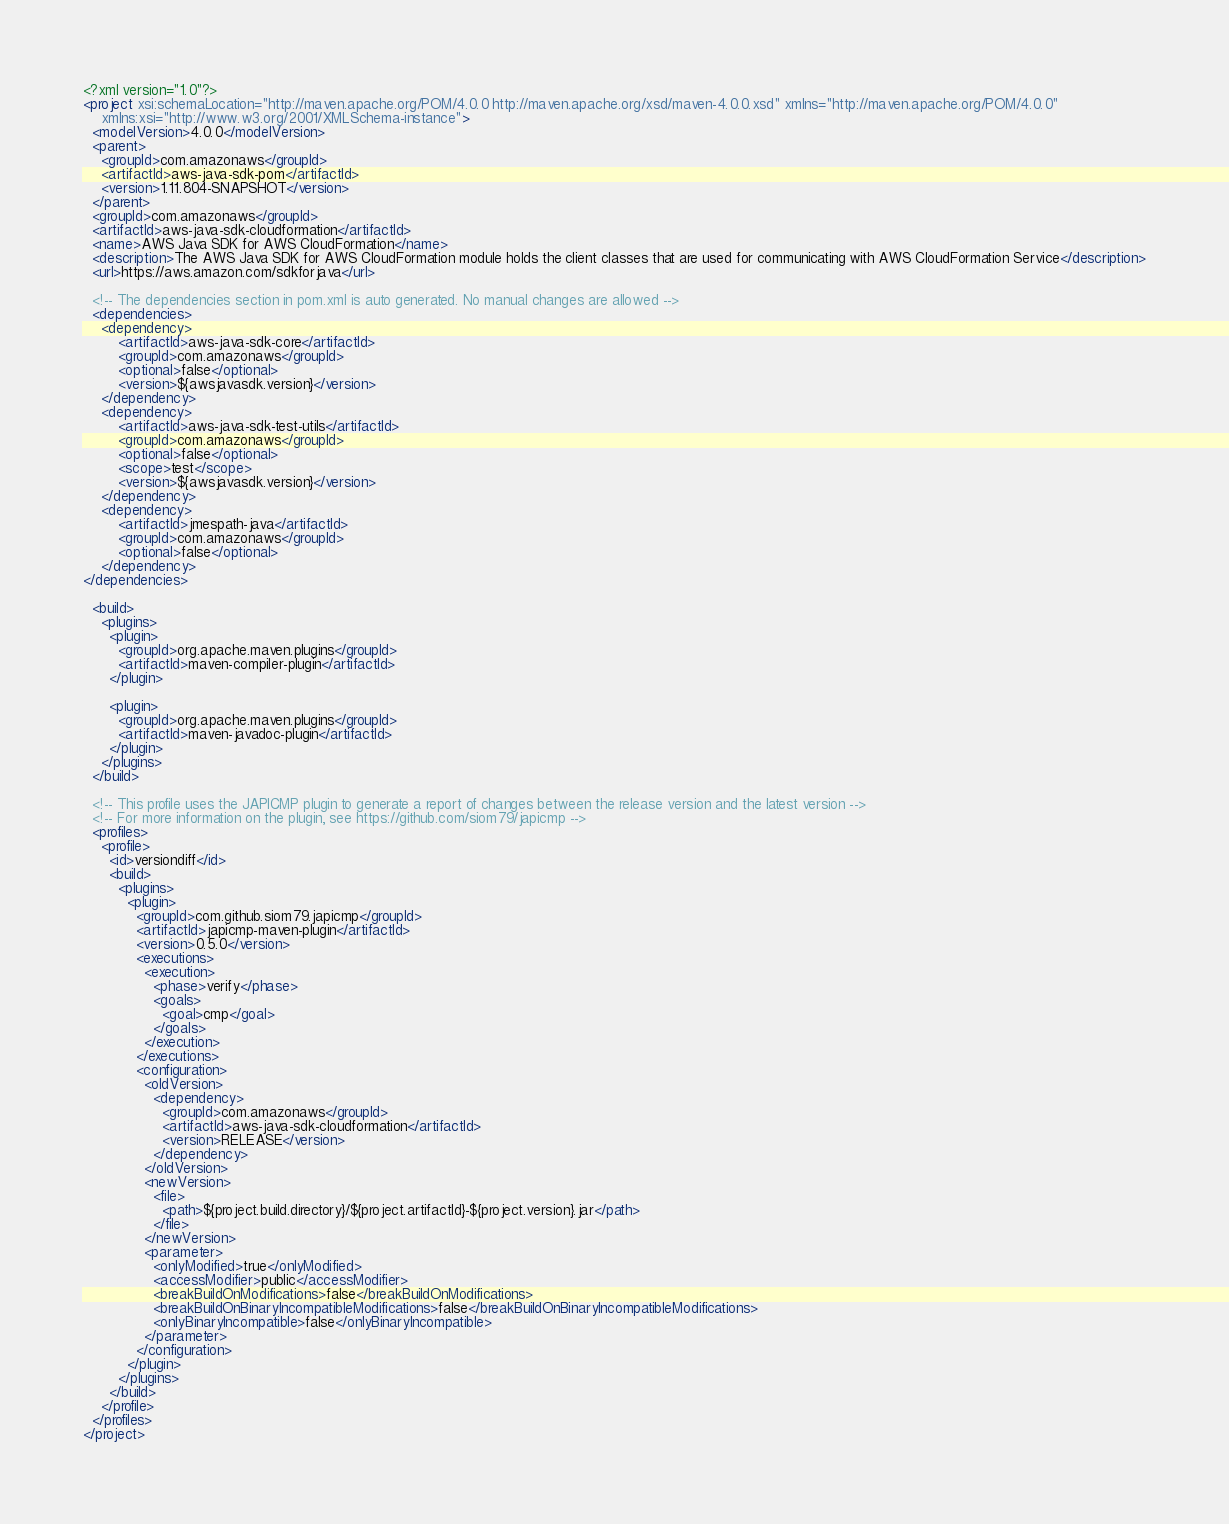<code> <loc_0><loc_0><loc_500><loc_500><_XML_><?xml version="1.0"?>
<project xsi:schemaLocation="http://maven.apache.org/POM/4.0.0 http://maven.apache.org/xsd/maven-4.0.0.xsd" xmlns="http://maven.apache.org/POM/4.0.0"
    xmlns:xsi="http://www.w3.org/2001/XMLSchema-instance">
  <modelVersion>4.0.0</modelVersion>
  <parent>
    <groupId>com.amazonaws</groupId>
    <artifactId>aws-java-sdk-pom</artifactId>
    <version>1.11.804-SNAPSHOT</version>
  </parent>
  <groupId>com.amazonaws</groupId>
  <artifactId>aws-java-sdk-cloudformation</artifactId>
  <name>AWS Java SDK for AWS CloudFormation</name>
  <description>The AWS Java SDK for AWS CloudFormation module holds the client classes that are used for communicating with AWS CloudFormation Service</description>
  <url>https://aws.amazon.com/sdkforjava</url>

  <!-- The dependencies section in pom.xml is auto generated. No manual changes are allowed -->
  <dependencies>
    <dependency>
        <artifactId>aws-java-sdk-core</artifactId>
        <groupId>com.amazonaws</groupId>
        <optional>false</optional>
        <version>${awsjavasdk.version}</version>
    </dependency>
    <dependency>
        <artifactId>aws-java-sdk-test-utils</artifactId>
        <groupId>com.amazonaws</groupId>
        <optional>false</optional>
        <scope>test</scope>
        <version>${awsjavasdk.version}</version>
    </dependency>
    <dependency>
        <artifactId>jmespath-java</artifactId>
        <groupId>com.amazonaws</groupId>
        <optional>false</optional>
    </dependency>
</dependencies>

  <build>
    <plugins>
      <plugin>
        <groupId>org.apache.maven.plugins</groupId>
        <artifactId>maven-compiler-plugin</artifactId>
      </plugin>

      <plugin>
        <groupId>org.apache.maven.plugins</groupId>
        <artifactId>maven-javadoc-plugin</artifactId>
      </plugin>
    </plugins>
  </build>

  <!-- This profile uses the JAPICMP plugin to generate a report of changes between the release version and the latest version -->
  <!-- For more information on the plugin, see https://github.com/siom79/japicmp -->
  <profiles>
    <profile>
      <id>versiondiff</id>
      <build>
        <plugins>
          <plugin>
            <groupId>com.github.siom79.japicmp</groupId>
            <artifactId>japicmp-maven-plugin</artifactId>
            <version>0.5.0</version>
            <executions>
              <execution>
                <phase>verify</phase>
                <goals>
                  <goal>cmp</goal>
                </goals>
              </execution>
            </executions>
            <configuration>
              <oldVersion>
                <dependency>
                  <groupId>com.amazonaws</groupId>
                  <artifactId>aws-java-sdk-cloudformation</artifactId>
                  <version>RELEASE</version>
                </dependency>
              </oldVersion>
              <newVersion>
                <file>
                  <path>${project.build.directory}/${project.artifactId}-${project.version}.jar</path>
                </file>
              </newVersion>
              <parameter>
                <onlyModified>true</onlyModified>
                <accessModifier>public</accessModifier>
                <breakBuildOnModifications>false</breakBuildOnModifications>
                <breakBuildOnBinaryIncompatibleModifications>false</breakBuildOnBinaryIncompatibleModifications>
                <onlyBinaryIncompatible>false</onlyBinaryIncompatible>
              </parameter>
            </configuration>
          </plugin>
        </plugins>
      </build>
    </profile>
  </profiles>
</project>
</code> 